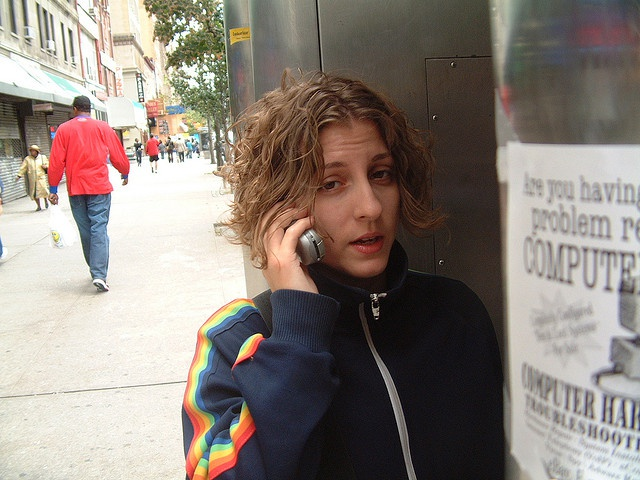Describe the objects in this image and their specific colors. I can see people in lightgray, black, brown, and maroon tones, people in lightgray, salmon, white, gray, and red tones, people in lightgray, tan, and beige tones, cell phone in lightgray, maroon, gray, and black tones, and people in lightgray, salmon, white, lightpink, and red tones in this image. 